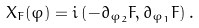Convert formula to latex. <formula><loc_0><loc_0><loc_500><loc_500>X _ { F } ( \varphi ) = i \left ( - \partial _ { \varphi _ { 2 } } F , \partial _ { \varphi _ { 1 } } F \right ) .</formula> 